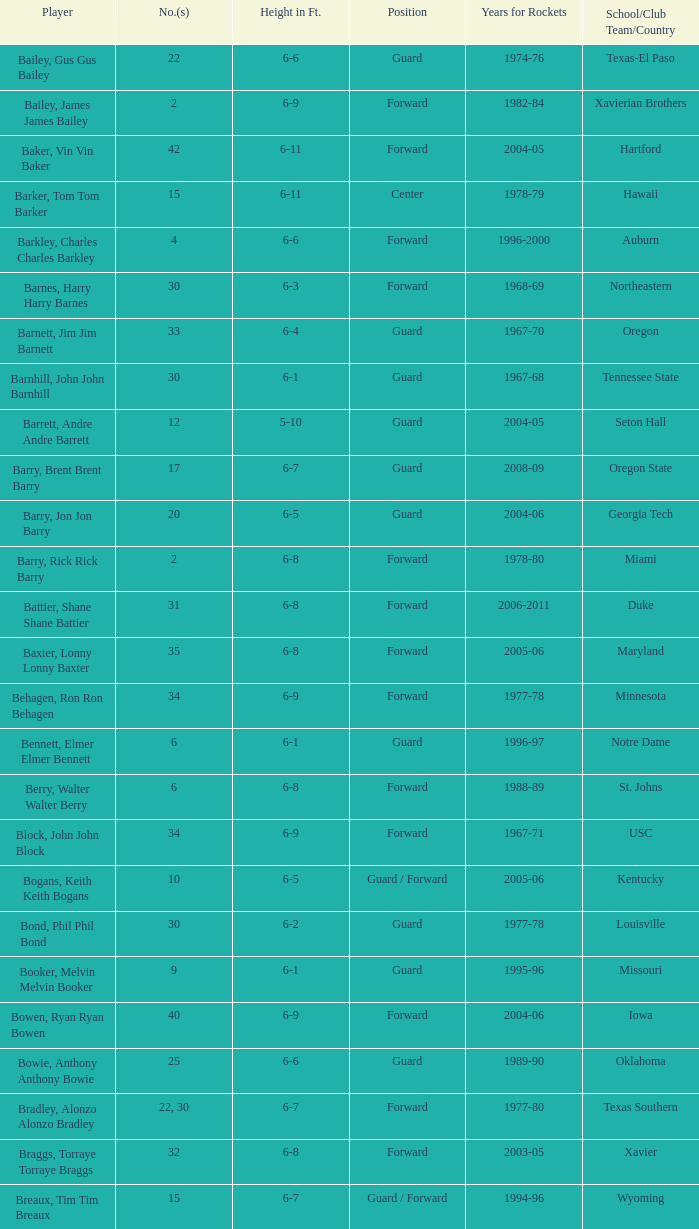What is the position of the person with number 35 and a height of 6-6? Forward. 